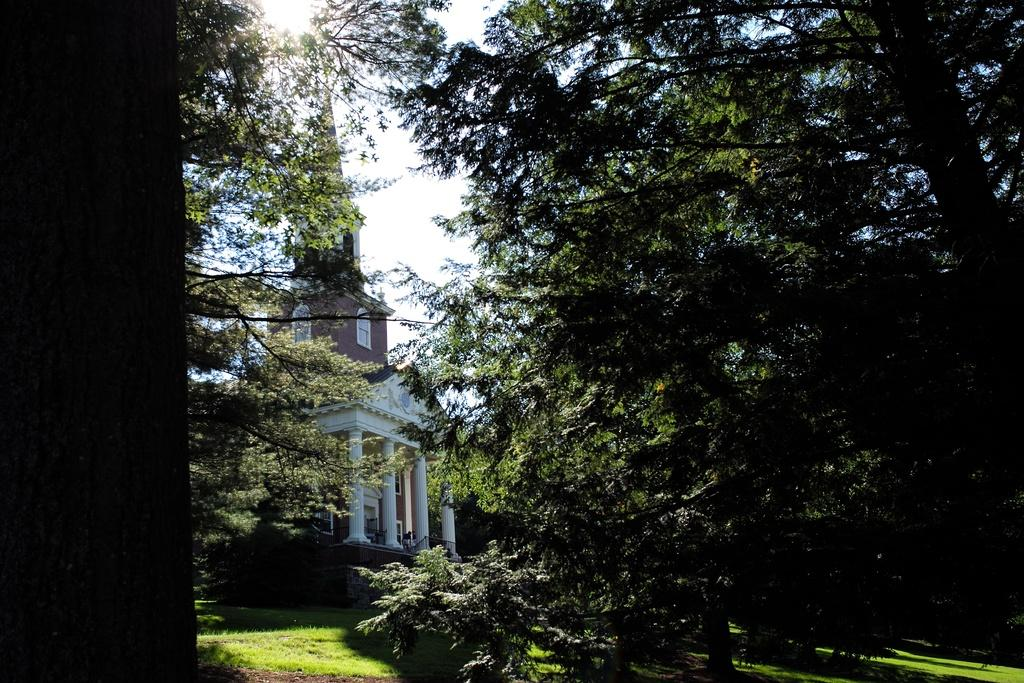What type of vegetation is present in the image? There are trees in the image. What type of ground cover is present in the image? There is grass in the image. What type of structure is present in the image? There is a building in the image. What celestial body is visible in the image? The sun is visible in the image. What part of the natural environment is visible in the image? The sky is visible in the background of the image. Can you see any cakes being served in the image? There is no reference to cakes or any food items in the image. What type of camping equipment is visible in the image? There is no camping equipment present in the image. 